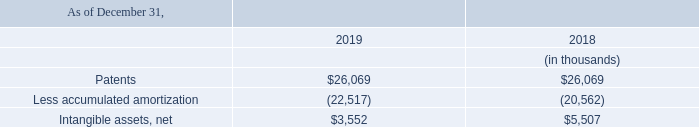Patents and Intangible Assets
The Company owns or possesses licenses to use its patents. The costs of maintaining the patents are expensed as incurred.
The Company and Finjan Blue entered into a Patent Assignment and Support Agreement (the “Patent Assignment Agreement”) with IBM effective as of August 24, 2017 (see "Note 7 - Commitments and Contingencies"). Pursuant to the Patent Assignment Agreement, Finjan Blue acquired select IBM patents in the security sector. In accordance with ASC 350-30-35-2 through 35-4, Intangibles-Goodwill and Other, the Company determined that the useful life of the patents acquired under the Patent Assignment and Support Agreement should be amortized over the four-year term of the agreement.
On May 15, 2018, Finjan Blue, entered into a second agreement with IBM (the “May 2018 Patent Assignment Agreement”). Pursuant to the May 2018 Patent Assignment Agreement, Finjan Blue acquired 56 select issued and pending IBM patents in the security sector. The terms of the May 2018 Patent Assignment Agreement are confidential. In accordance with ASC 350-30-35-2 through 35-4, Intangibles-Goodwill and Other, the Company determined that the useful life of the patents acquired under the May 2018 Patent Assignment Agreement should be amortized over five years as the covenants between the parties are effective for that period.
Management did not identify any triggering events which would have necessitated an impairment change.
The components of these intangible assets are as follows:
Amortization expense for the years ended December 31, 2019, 2018 and 2017 was approximately $2.0 million, $1.8 million, and $0.8 million, respectively.
What are the respective values of patents in 2019 and 2018?
Answer scale should be: thousand. $26,069, $26,069. What are the respective values of accumulated patent amortization in 2019 and 2018?
Answer scale should be: thousand. 22,517, 20,562. What are the respective values of net intangible assets in 2019 and 2018?
Answer scale should be: thousand. $3,552, $5,507. What is the percentage change in the value of patents between 2018 and 2019?
Answer scale should be: percent. (26,069 - 26,069)/26,069 
Answer: 0. What is the percentage change in the value of net intangible assets between 2018 and 2019?
Answer scale should be: percent. (3,552 - 5,507)/5,507 
Answer: -35.5. What is the change in net intangible assets between 2018 and 2019?
Answer scale should be: thousand. 5,507-3,552
Answer: 1955. 